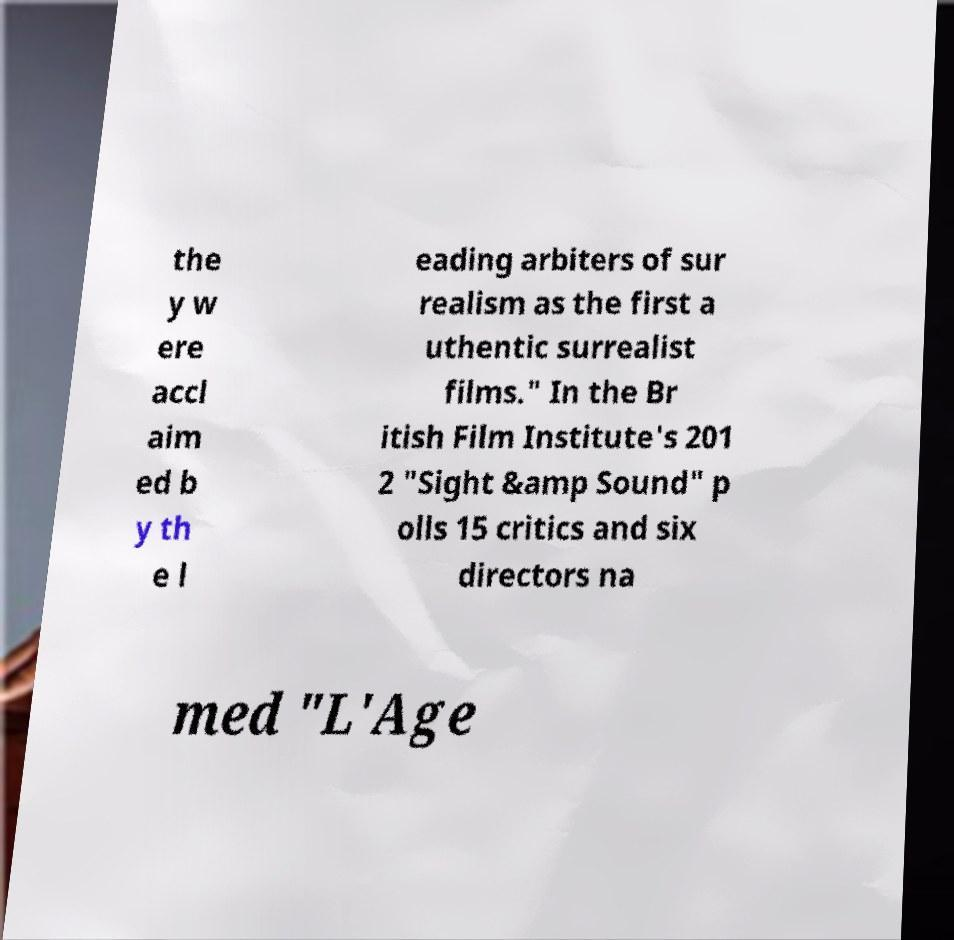What messages or text are displayed in this image? I need them in a readable, typed format. the y w ere accl aim ed b y th e l eading arbiters of sur realism as the first a uthentic surrealist films." In the Br itish Film Institute's 201 2 "Sight &amp Sound" p olls 15 critics and six directors na med "L'Age 